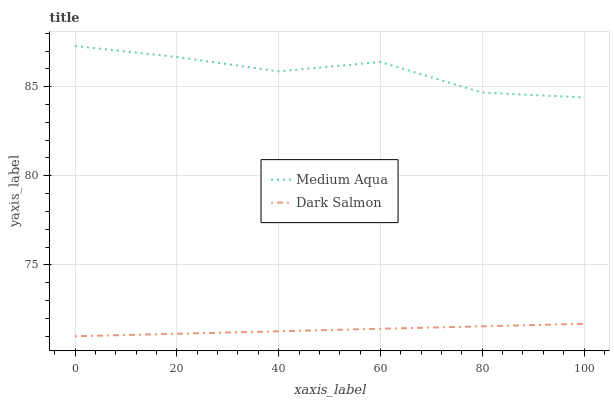Does Dark Salmon have the minimum area under the curve?
Answer yes or no. Yes. Does Medium Aqua have the maximum area under the curve?
Answer yes or no. Yes. Does Dark Salmon have the maximum area under the curve?
Answer yes or no. No. Is Dark Salmon the smoothest?
Answer yes or no. Yes. Is Medium Aqua the roughest?
Answer yes or no. Yes. Is Dark Salmon the roughest?
Answer yes or no. No. Does Dark Salmon have the lowest value?
Answer yes or no. Yes. Does Medium Aqua have the highest value?
Answer yes or no. Yes. Does Dark Salmon have the highest value?
Answer yes or no. No. Is Dark Salmon less than Medium Aqua?
Answer yes or no. Yes. Is Medium Aqua greater than Dark Salmon?
Answer yes or no. Yes. Does Dark Salmon intersect Medium Aqua?
Answer yes or no. No. 